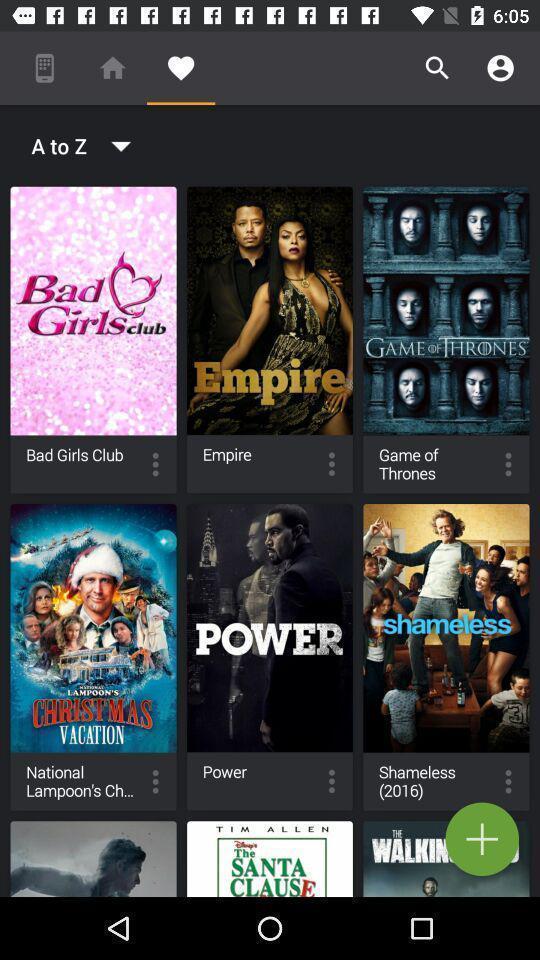Tell me what you see in this picture. Page displaying list of movies in app. 